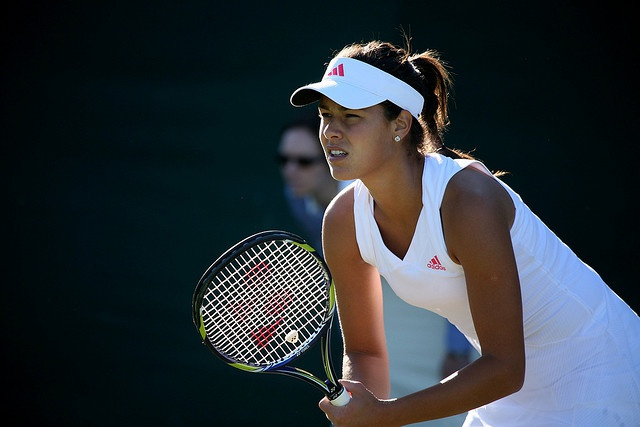Describe the objects in this image and their specific colors. I can see people in black, maroon, and darkgray tones, tennis racket in black, white, gray, and darkgray tones, and people in black, gray, navy, and darkblue tones in this image. 